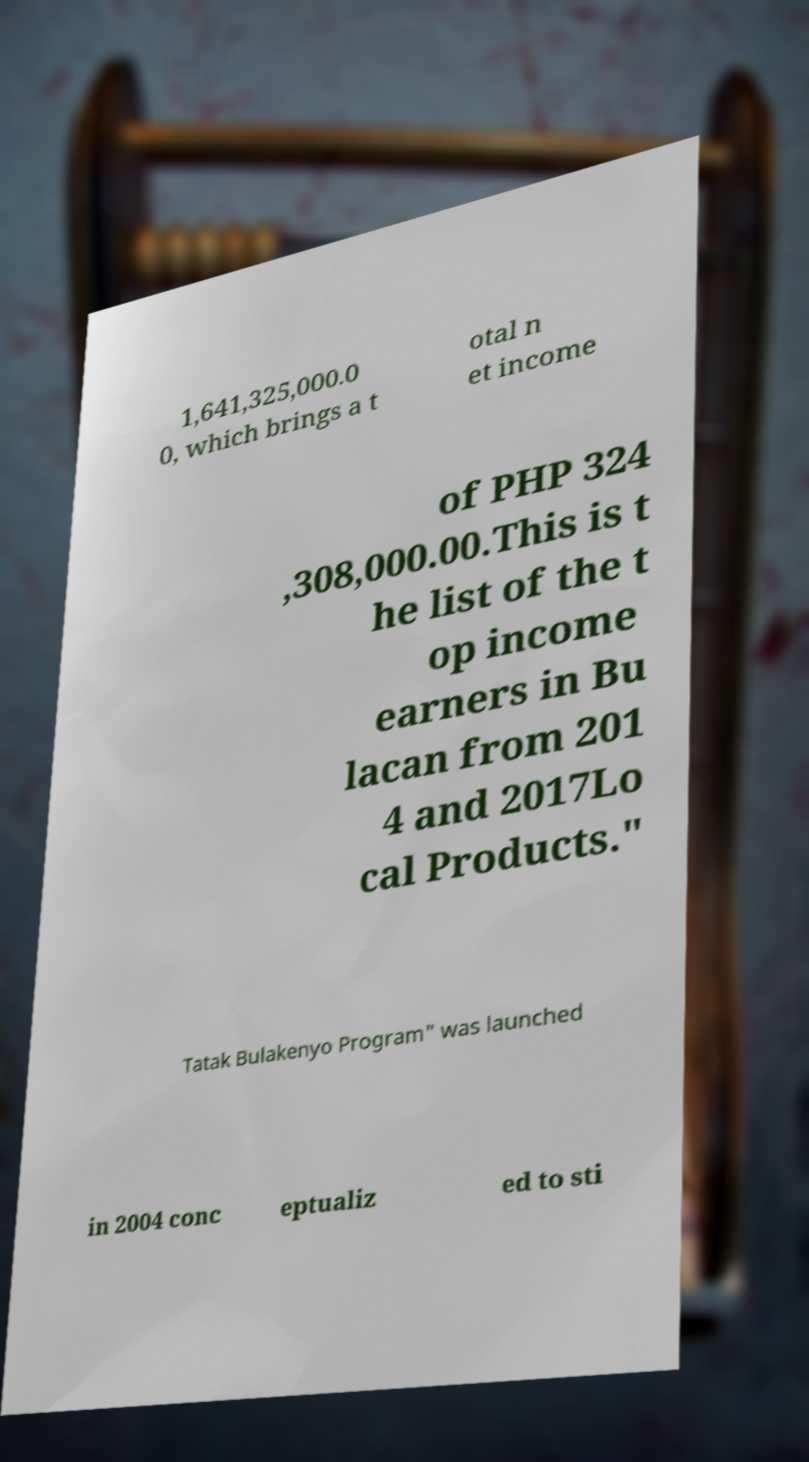Could you assist in decoding the text presented in this image and type it out clearly? 1,641,325,000.0 0, which brings a t otal n et income of PHP 324 ,308,000.00.This is t he list of the t op income earners in Bu lacan from 201 4 and 2017Lo cal Products." Tatak Bulakenyo Program" was launched in 2004 conc eptualiz ed to sti 